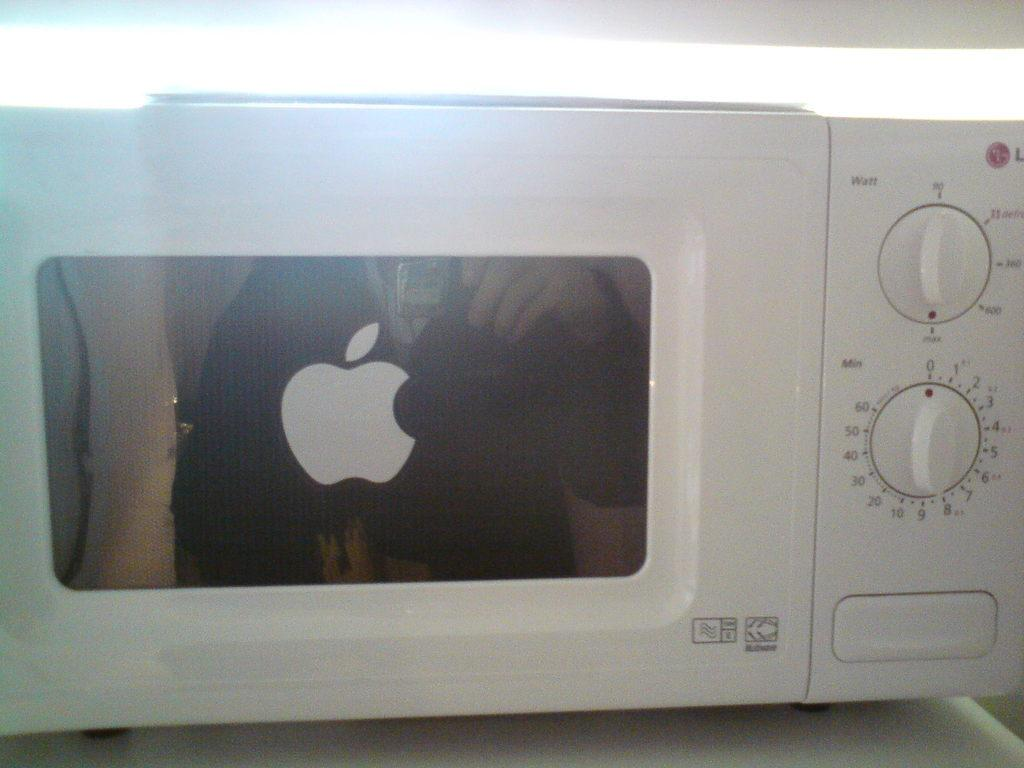<image>
Describe the image concisely. A white microwave oven with an Apple logo sticker on the door. 